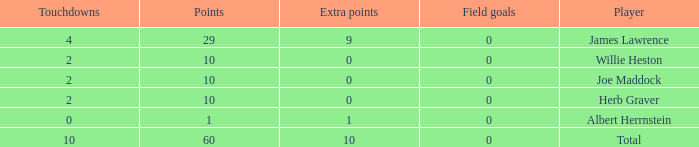What is the average number of points for players with 4 touchdowns and more than 0 field goals? None. 